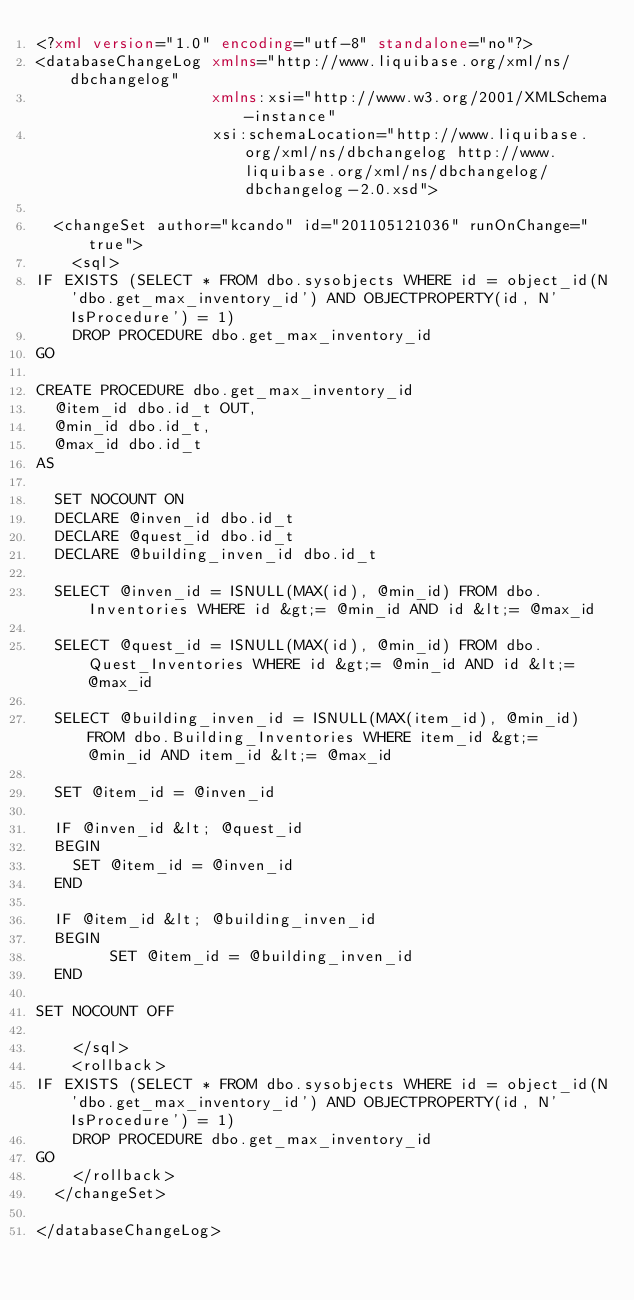Convert code to text. <code><loc_0><loc_0><loc_500><loc_500><_XML_><?xml version="1.0" encoding="utf-8" standalone="no"?>
<databaseChangeLog xmlns="http://www.liquibase.org/xml/ns/dbchangelog"
                   xmlns:xsi="http://www.w3.org/2001/XMLSchema-instance"
                   xsi:schemaLocation="http://www.liquibase.org/xml/ns/dbchangelog http://www.liquibase.org/xml/ns/dbchangelog/dbchangelog-2.0.xsd">
  
  <changeSet author="kcando" id="201105121036" runOnChange="true">
    <sql>
IF EXISTS (SELECT * FROM dbo.sysobjects WHERE id = object_id(N'dbo.get_max_inventory_id') AND OBJECTPROPERTY(id, N'IsProcedure') = 1)
	DROP PROCEDURE dbo.get_max_inventory_id
GO

CREATE PROCEDURE dbo.get_max_inventory_id
  @item_id dbo.id_t OUT,
  @min_id dbo.id_t,
  @max_id dbo.id_t
AS

  SET NOCOUNT ON
  DECLARE @inven_id dbo.id_t
  DECLARE @quest_id dbo.id_t
  DECLARE @building_inven_id dbo.id_t

  SELECT @inven_id = ISNULL(MAX(id), @min_id) FROM dbo.Inventories WHERE id &gt;= @min_id AND id &lt;= @max_id 
                                                                                                 
  SELECT @quest_id = ISNULL(MAX(id), @min_id) FROM dbo.Quest_Inventories WHERE id &gt;= @min_id AND id &lt;= @max_id
                                                                                                       
  SELECT @building_inven_id = ISNULL(MAX(item_id), @min_id) FROM dbo.Building_Inventories WHERE item_id &gt;= @min_id AND item_id &lt;= @max_id

  SET @item_id = @inven_id 
  
  IF @inven_id &lt; @quest_id
  BEGIN
	SET @item_id = @inven_id
  END
  
  IF @item_id &lt; @building_inven_id 
  BEGIN
        SET @item_id = @building_inven_id
  END
    
SET NOCOUNT OFF

    </sql>
    <rollback>
IF EXISTS (SELECT * FROM dbo.sysobjects WHERE id = object_id(N'dbo.get_max_inventory_id') AND OBJECTPROPERTY(id, N'IsProcedure') = 1)
	DROP PROCEDURE dbo.get_max_inventory_id
GO
    </rollback>
  </changeSet>

</databaseChangeLog>
</code> 